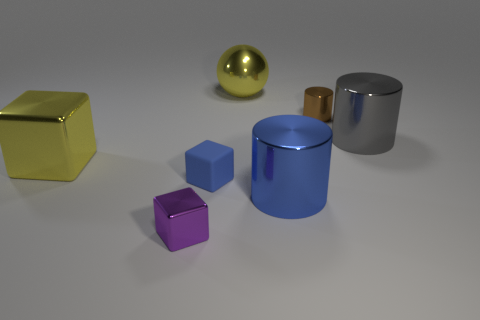Subtract all big yellow blocks. How many blocks are left? 2 Subtract 2 cylinders. How many cylinders are left? 1 Subtract all blue cubes. How many cubes are left? 2 Add 2 brown matte cylinders. How many objects exist? 9 Subtract all spheres. How many objects are left? 6 Subtract all cyan cubes. How many gray cylinders are left? 1 Subtract all purple spheres. Subtract all purple cylinders. How many spheres are left? 1 Add 3 big cyan things. How many big cyan things exist? 3 Subtract 0 brown blocks. How many objects are left? 7 Subtract all large green rubber cubes. Subtract all blue cubes. How many objects are left? 6 